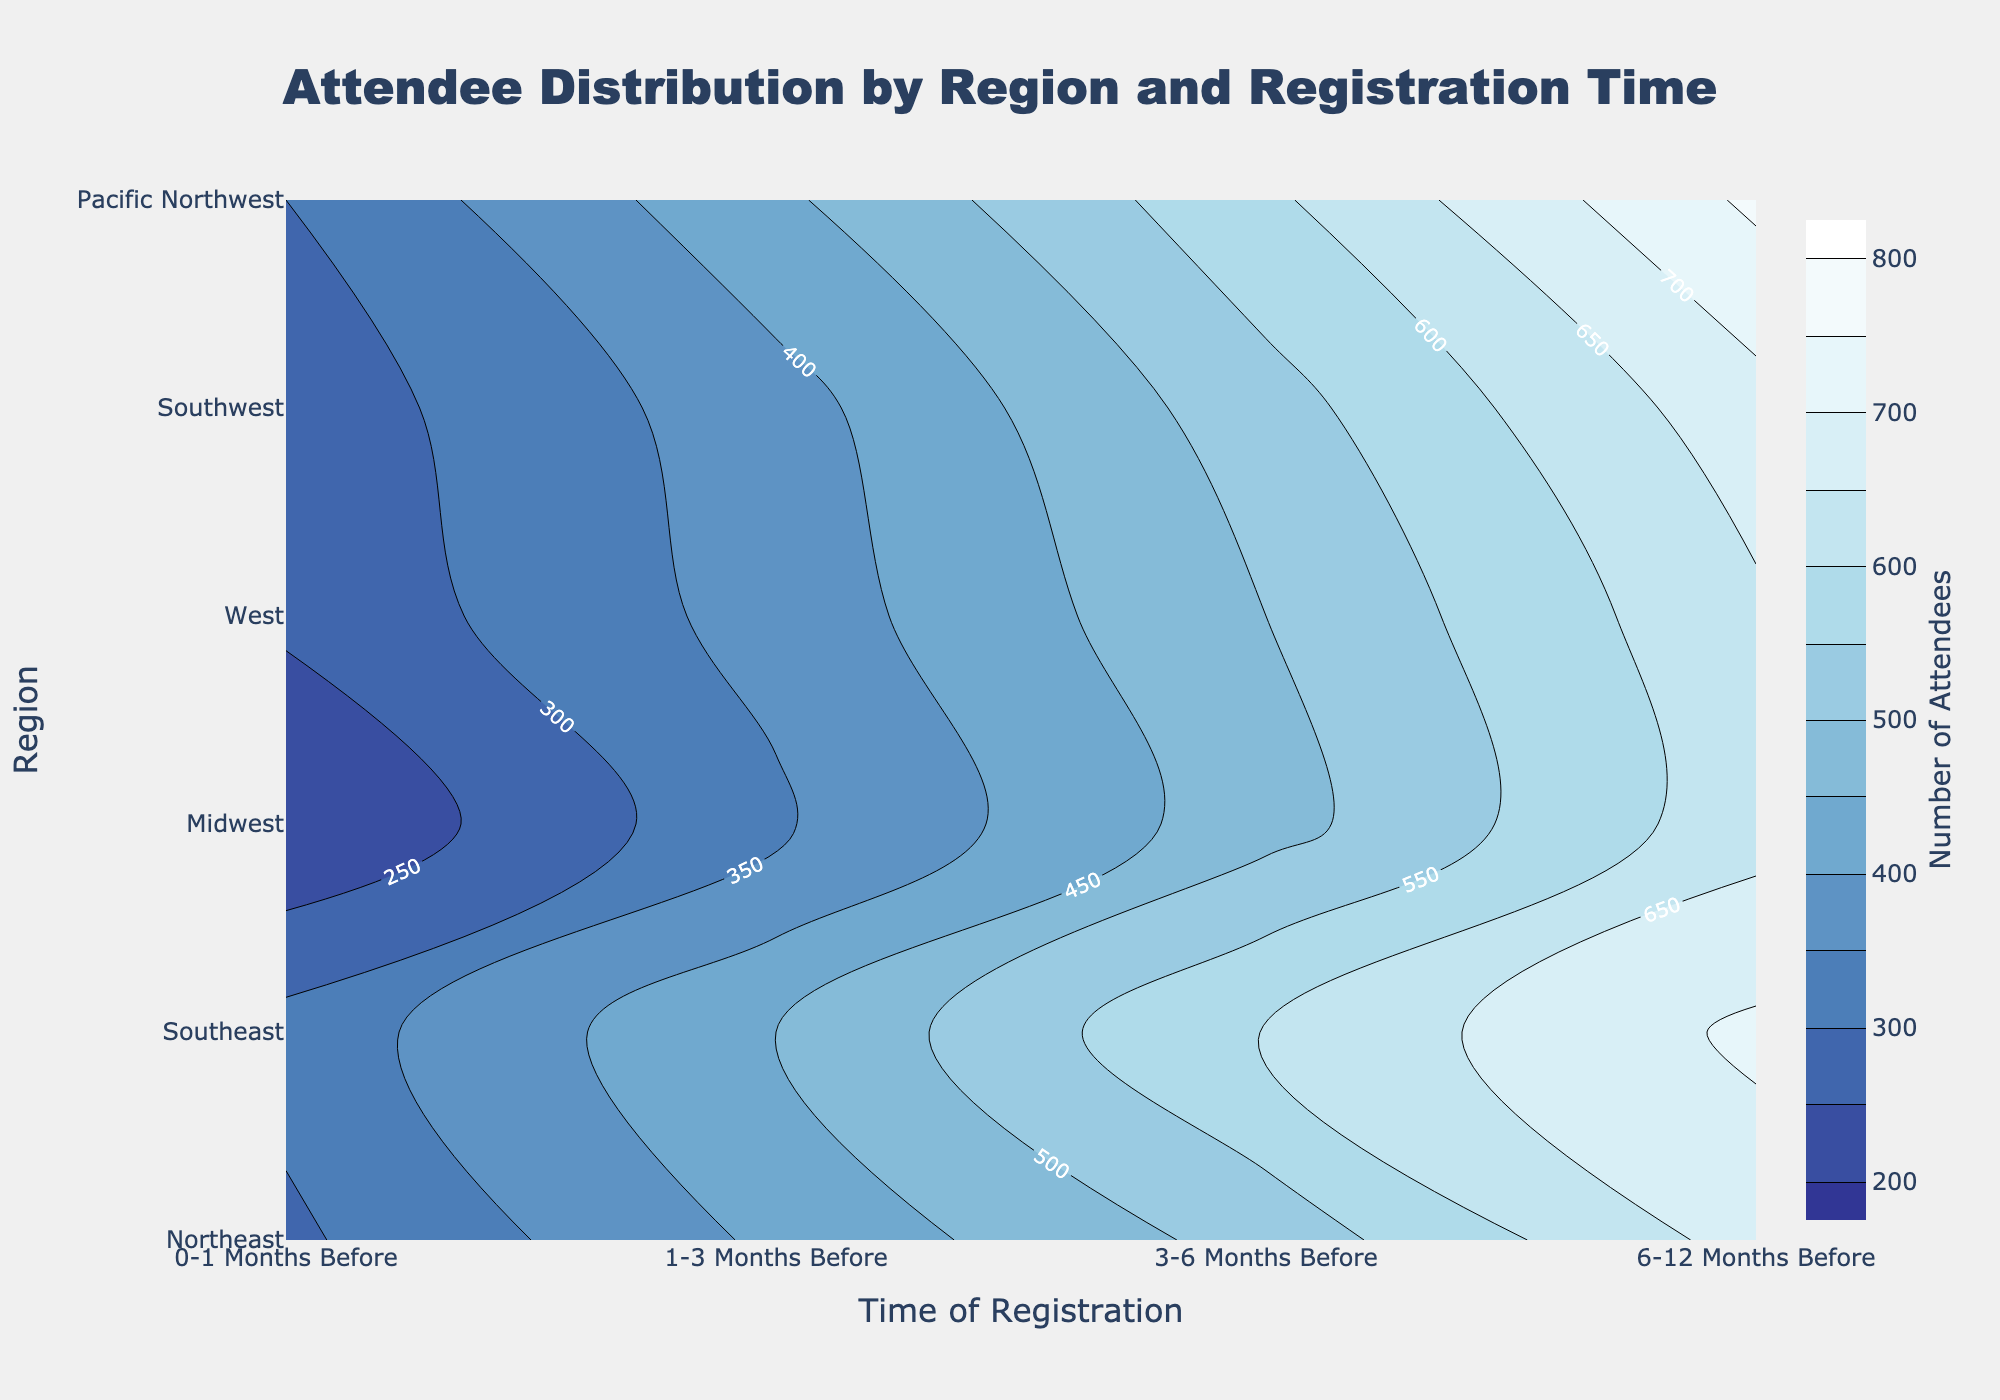What is the title of the figure? The title is located at the top of the figure in a bold, large font. It provides a summary of what the figure represents.
Answer: Attendee Distribution by Region and Registration Time Which region has the highest number of attendees who register 6-12 months before the conference? By looking at the highest values on the y-axis corresponding to the 6-12 months period on the x-axis, you can see which region has the maximum value. The contour lines and color intensity help identify this region.
Answer: West What is the range of the number of attendees visualized in this contour plot? The color bar on the right side of the plot indicates the range of values depicted in the plot, showing the minimum and maximum values for the number of attendees.
Answer: 200-800 Which two regions have the closest number of attendees for the 1-3 months before registration period? By examining the contour lines or colors for the 1-3 months period, find two regions that have nearly identical values.
Answer: Southeast and Southwest What is the overall trend in attendee registration as the time of registration approaches the conference date in each region? By examining the contour lines or colors across all regions from 6-12 months to 0-1 month, you can see whether the number of attendees increases or decreases.
Answer: Decrease Is there any region where attendees registering 6-12 months before make up less than half the number of attendees who register 0-1 months before? Identify a region where the value for 6-12 months is less than half of the value for 0-1 months by comparing the numbers from the contour lines or colors.
Answer: No What is the difference in the number of attendees between the Midwest and the Northeast for the 3-6 months before registration period? Find the values on the contour plot for both regions at the 3-6 months time period and subtract the Northeast value from the Midwest value to find the difference.
Answer: -90 Which region shows the most gradual increase in attendees as the registration time gets closer to the conference date? Examine the spacing and gradient of contour lines or color changes for all regions, identifying the one with the smoothest transition.
Answer: Pacific Northwest 